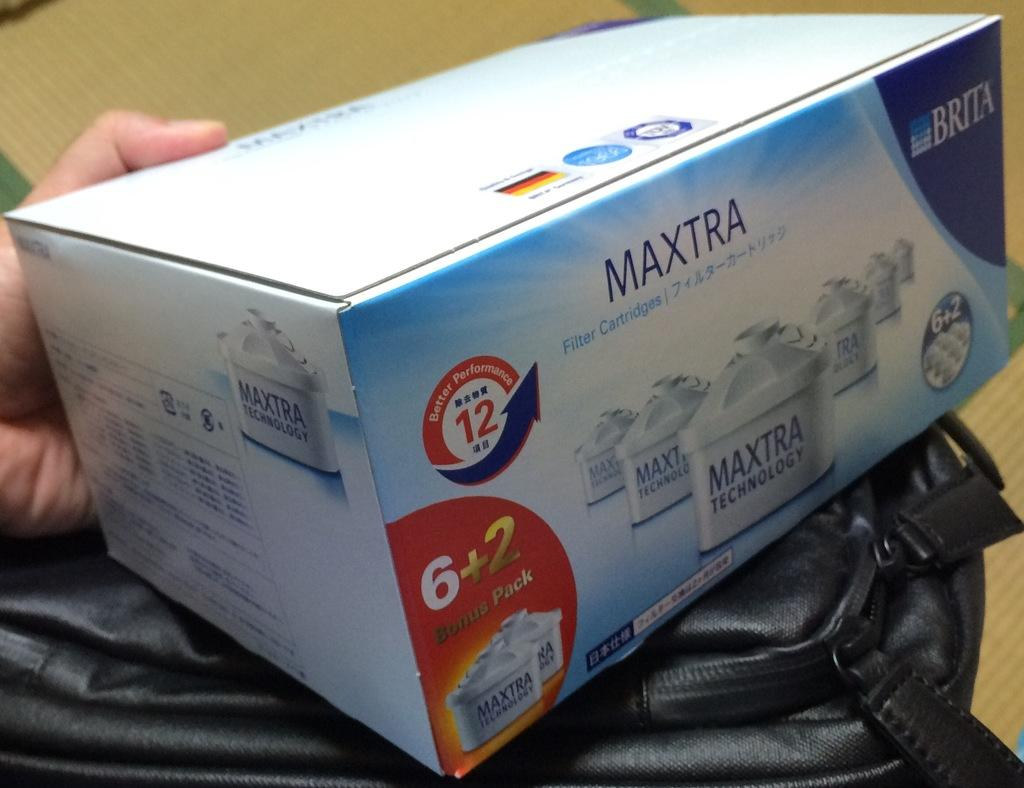<image>
Relay a brief, clear account of the picture shown. Maxtra Technology Filter Cartridges presented by Brita, contains a bonus pack of 6 and 2. 